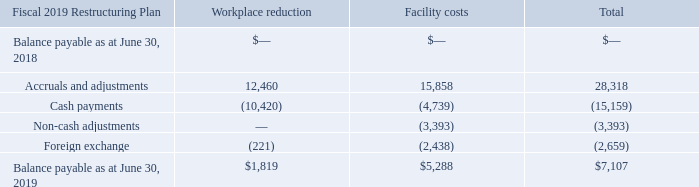Fiscal 2019 Restructuring Plan
During Fiscal 2019, we began to implement restructuring activities to streamline our operations (Fiscal 2019 Restructuring Plan), including in connection with our recent acquisitions of Catalyst and Liaison, to take further steps to improve our operational efficiency. The Fiscal 2019 Restructuring Plan charges relate to workforce reductions and facility consolidations. These charges require management to make certain judgments and estimates regarding the amount and timing of restructuring charges or recoveries. Our estimated liability could change subsequent to its recognition, requiring adjustments to the expense and the liability recorded. On a quarterly basis, we conduct an evaluation of the related liabilities and expenses and revise our assumptions and estimates as appropriate.
As of June 30, 2019, we expect total costs to be incurred in conjunction with the Fiscal 2019 Restructuring Plan to be approximately $30.0 million, of which $28.3 million has already been recorded within "Special charges (recoveries)" to date. We do not expect to incur any further significant charges relating to this plan.
A reconciliation of the beginning and ending liability for the year ended June 30, 2019 is shown below.
What does the table show? Reconciliation of the beginning and ending liability for the year ended june 30, 2019. What are the recent acquisitions of Fiscal 2019? Catalyst, liaison. What is the total Balance payable as at June 30, 2019 
Answer scale should be: thousand. 7,107. What is the Balance payable as at June 30, 2019 for Workplace reduction expressed as a percentage of total Balance payable?
Answer scale should be: percent. 1,819/7,107
Answer: 25.59. For Accruals and adjustments, What is difference between Workplace reduction & Facility costs?
Answer scale should be: thousand. 12,460-15,858
Answer: -3398. What is the difference between Balance payable as at June 30, 2019 for Workplace reduction & Facility costs?
Answer scale should be: thousand. 1,819-5,288
Answer: -3469. 